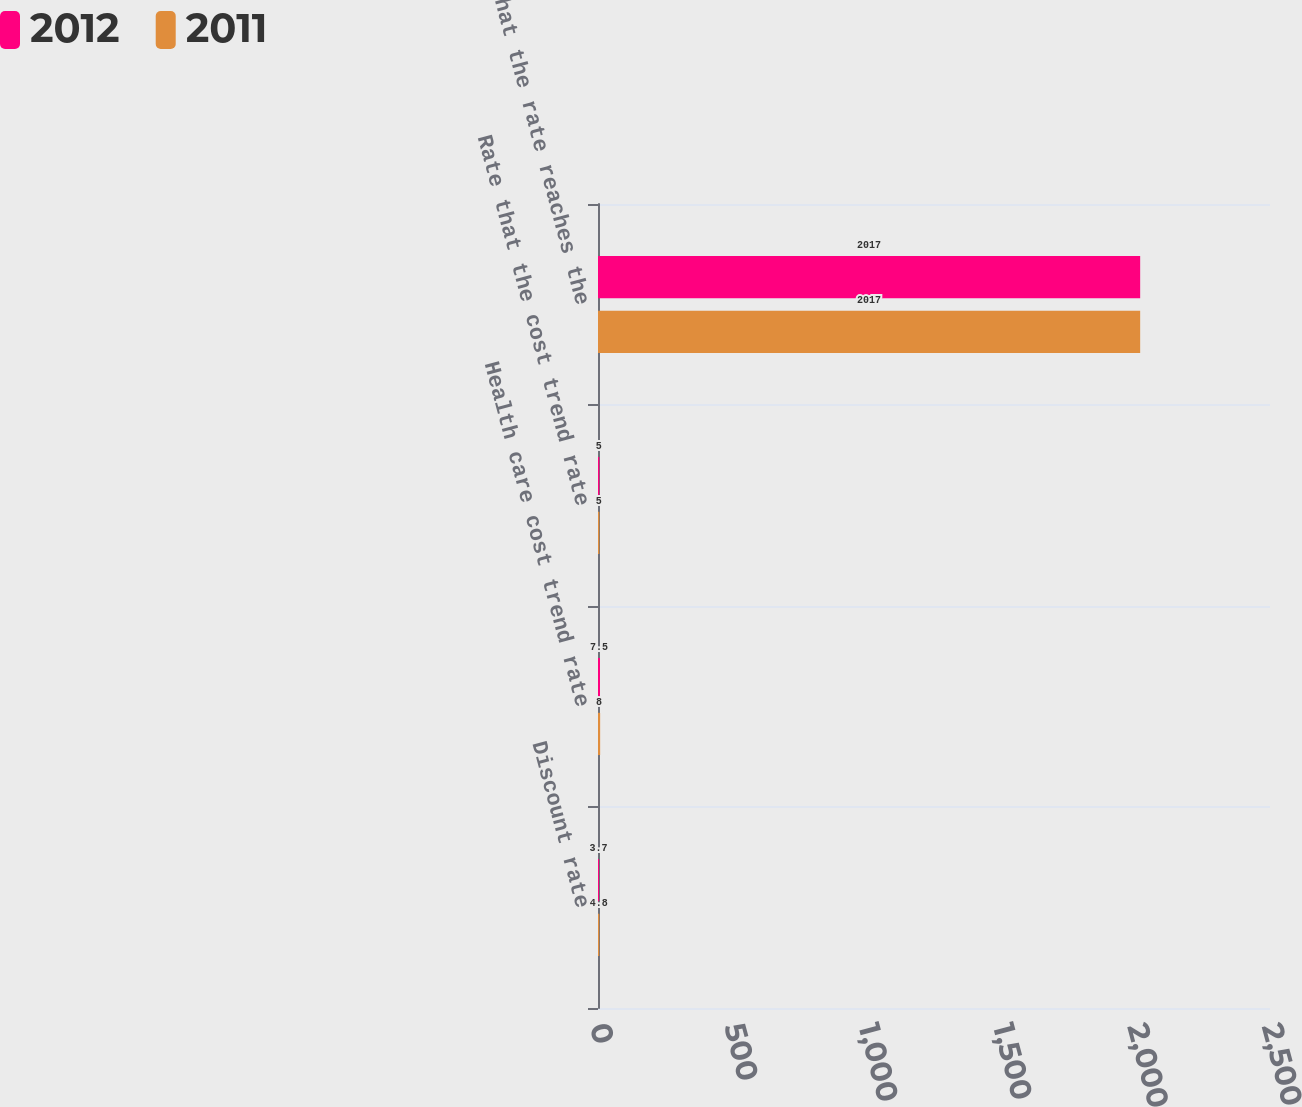Convert chart to OTSL. <chart><loc_0><loc_0><loc_500><loc_500><stacked_bar_chart><ecel><fcel>Discount rate<fcel>Health care cost trend rate<fcel>Rate that the cost trend rate<fcel>Year that the rate reaches the<nl><fcel>2012<fcel>3.7<fcel>7.5<fcel>5<fcel>2017<nl><fcel>2011<fcel>4.8<fcel>8<fcel>5<fcel>2017<nl></chart> 